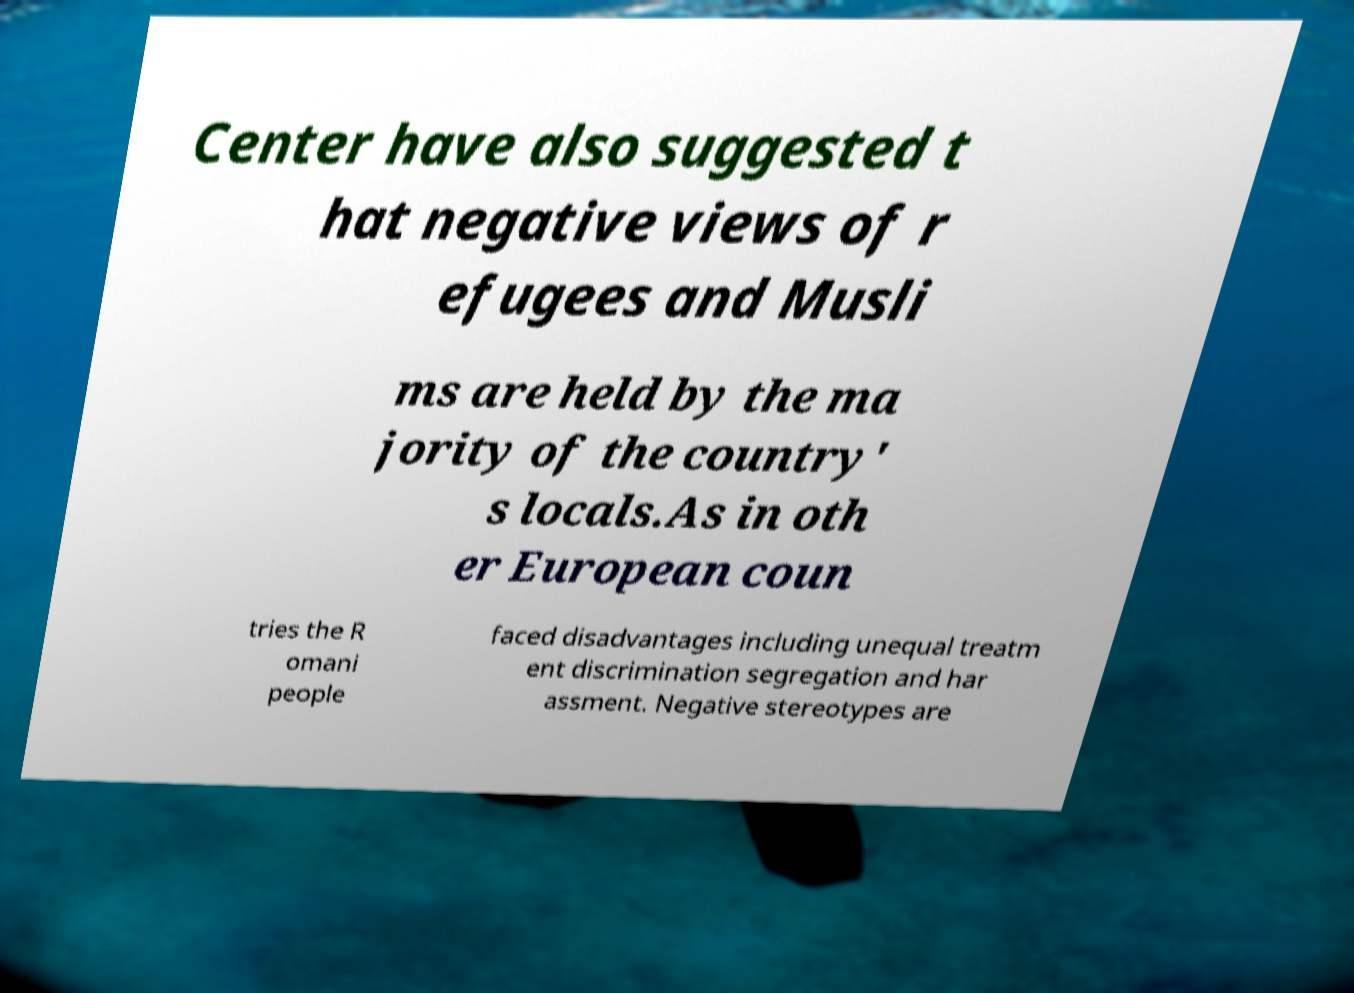I need the written content from this picture converted into text. Can you do that? Center have also suggested t hat negative views of r efugees and Musli ms are held by the ma jority of the country' s locals.As in oth er European coun tries the R omani people faced disadvantages including unequal treatm ent discrimination segregation and har assment. Negative stereotypes are 